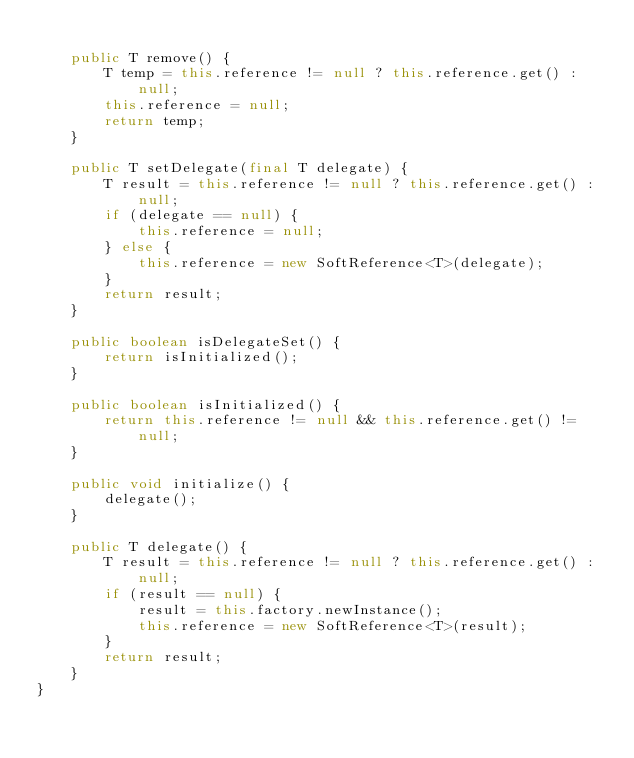Convert code to text. <code><loc_0><loc_0><loc_500><loc_500><_Java_>
	public T remove() {
		T temp = this.reference != null ? this.reference.get() : null;
		this.reference = null;
		return temp;
	}

	public T setDelegate(final T delegate) {
		T result = this.reference != null ? this.reference.get() : null;
		if (delegate == null) {
			this.reference = null;
		} else {
			this.reference = new SoftReference<T>(delegate);
		}
		return result;
	}

	public boolean isDelegateSet() {
		return isInitialized();
	}

	public boolean isInitialized() {
		return this.reference != null && this.reference.get() != null;
	}

	public void initialize() {
		delegate();
	}

	public T delegate() {
		T result = this.reference != null ? this.reference.get() : null;
		if (result == null) {
			result = this.factory.newInstance();
			this.reference = new SoftReference<T>(result);
		}
		return result;
	}
}
</code> 